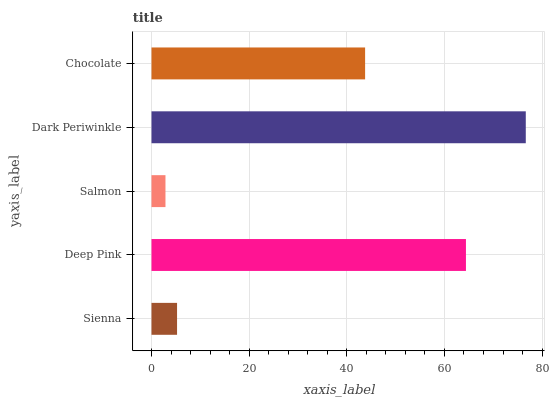Is Salmon the minimum?
Answer yes or no. Yes. Is Dark Periwinkle the maximum?
Answer yes or no. Yes. Is Deep Pink the minimum?
Answer yes or no. No. Is Deep Pink the maximum?
Answer yes or no. No. Is Deep Pink greater than Sienna?
Answer yes or no. Yes. Is Sienna less than Deep Pink?
Answer yes or no. Yes. Is Sienna greater than Deep Pink?
Answer yes or no. No. Is Deep Pink less than Sienna?
Answer yes or no. No. Is Chocolate the high median?
Answer yes or no. Yes. Is Chocolate the low median?
Answer yes or no. Yes. Is Sienna the high median?
Answer yes or no. No. Is Deep Pink the low median?
Answer yes or no. No. 